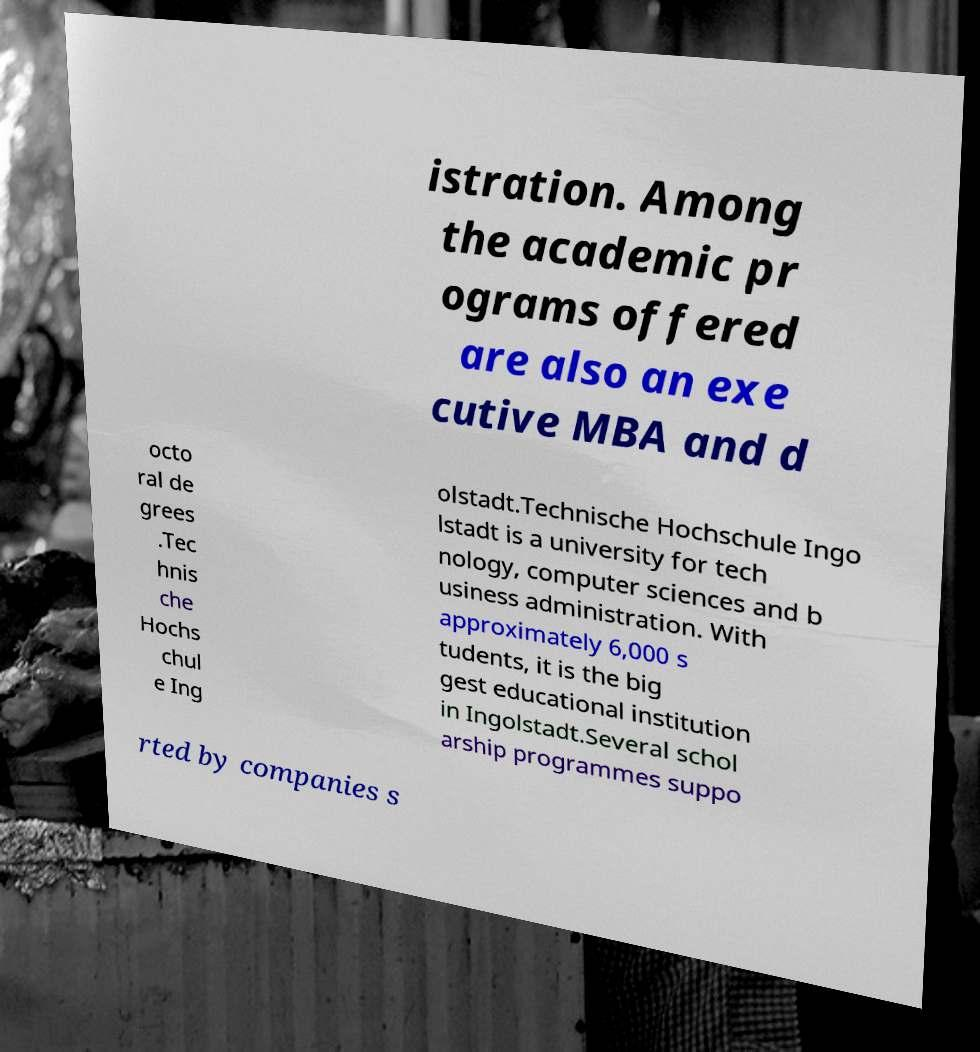What messages or text are displayed in this image? I need them in a readable, typed format. istration. Among the academic pr ograms offered are also an exe cutive MBA and d octo ral de grees .Tec hnis che Hochs chul e Ing olstadt.Technische Hochschule Ingo lstadt is a university for tech nology, computer sciences and b usiness administration. With approximately 6,000 s tudents, it is the big gest educational institution in Ingolstadt.Several schol arship programmes suppo rted by companies s 